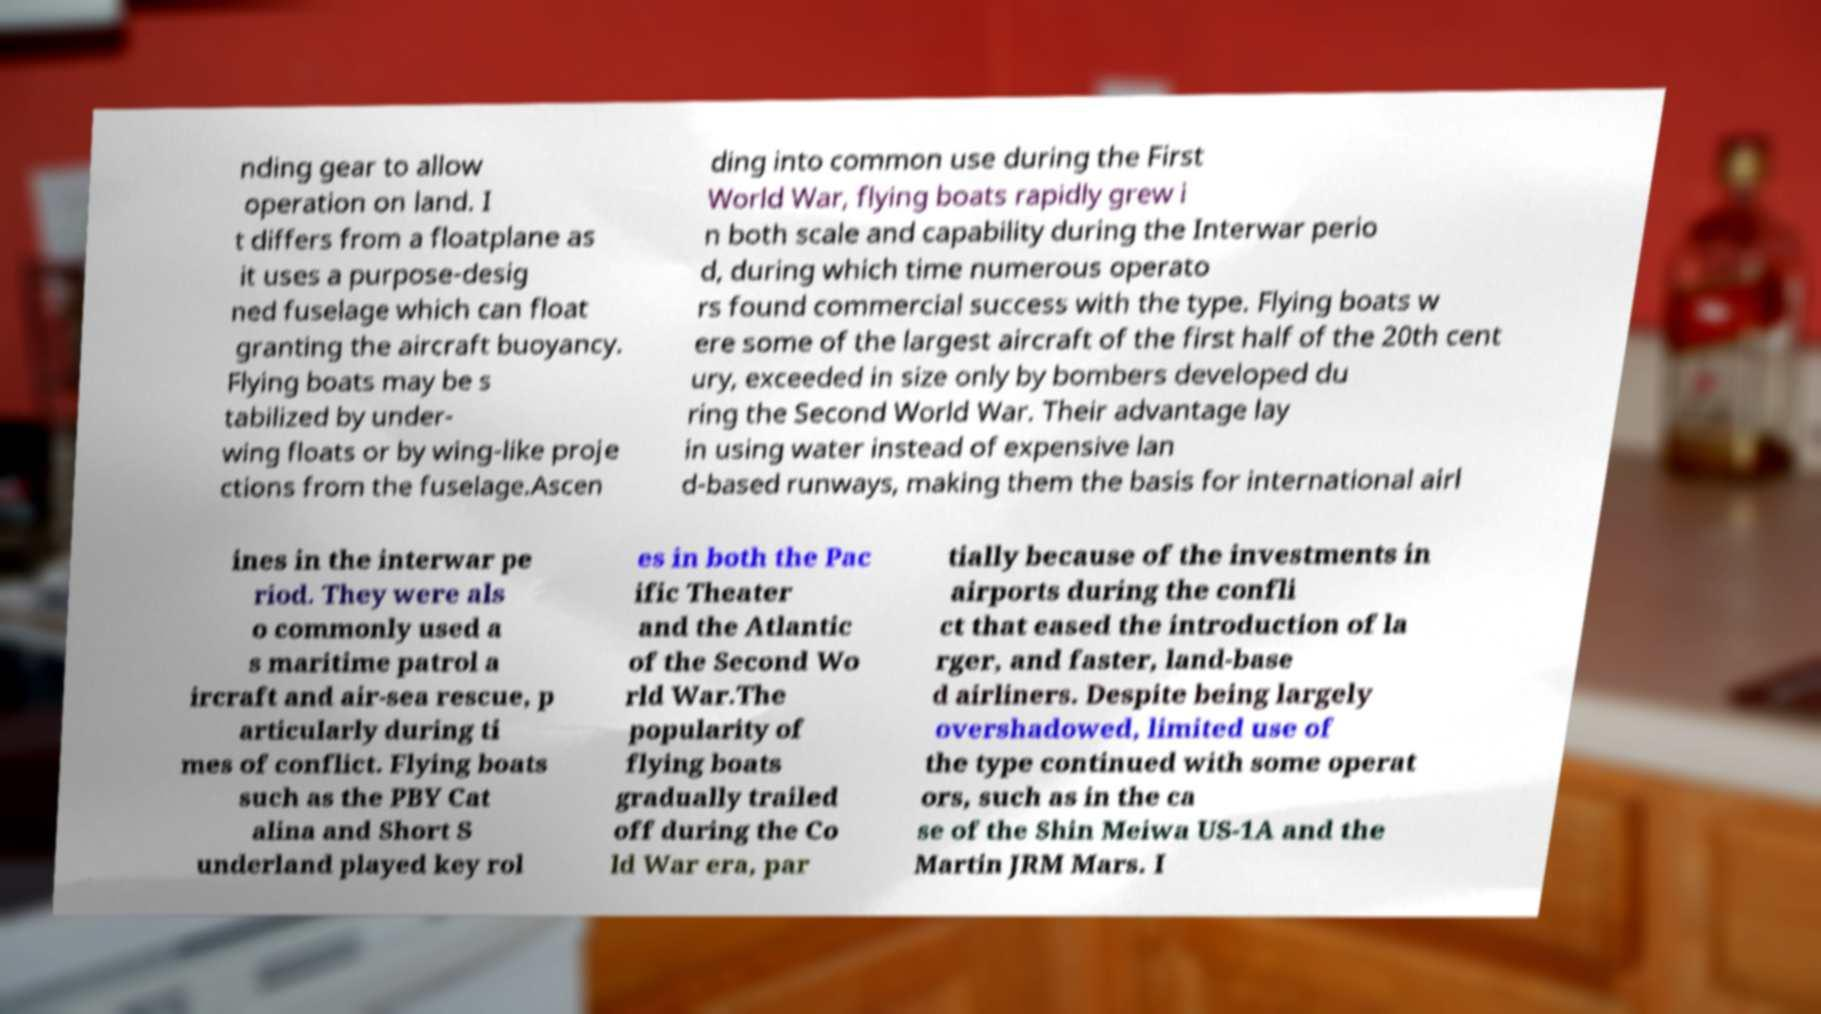For documentation purposes, I need the text within this image transcribed. Could you provide that? nding gear to allow operation on land. I t differs from a floatplane as it uses a purpose-desig ned fuselage which can float granting the aircraft buoyancy. Flying boats may be s tabilized by under- wing floats or by wing-like proje ctions from the fuselage.Ascen ding into common use during the First World War, flying boats rapidly grew i n both scale and capability during the Interwar perio d, during which time numerous operato rs found commercial success with the type. Flying boats w ere some of the largest aircraft of the first half of the 20th cent ury, exceeded in size only by bombers developed du ring the Second World War. Their advantage lay in using water instead of expensive lan d-based runways, making them the basis for international airl ines in the interwar pe riod. They were als o commonly used a s maritime patrol a ircraft and air-sea rescue, p articularly during ti mes of conflict. Flying boats such as the PBY Cat alina and Short S underland played key rol es in both the Pac ific Theater and the Atlantic of the Second Wo rld War.The popularity of flying boats gradually trailed off during the Co ld War era, par tially because of the investments in airports during the confli ct that eased the introduction of la rger, and faster, land-base d airliners. Despite being largely overshadowed, limited use of the type continued with some operat ors, such as in the ca se of the Shin Meiwa US-1A and the Martin JRM Mars. I 